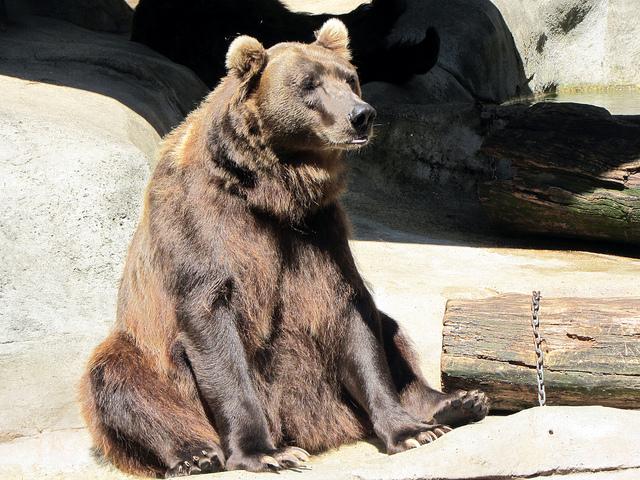Is the animal sitting?
Quick response, please. Yes. Is this animal going to attack now?
Quick response, please. No. What animal is shown?
Keep it brief. Bear. What kind of animals are seen here?
Write a very short answer. Bear. Is this bear in the wild?
Be succinct. No. 